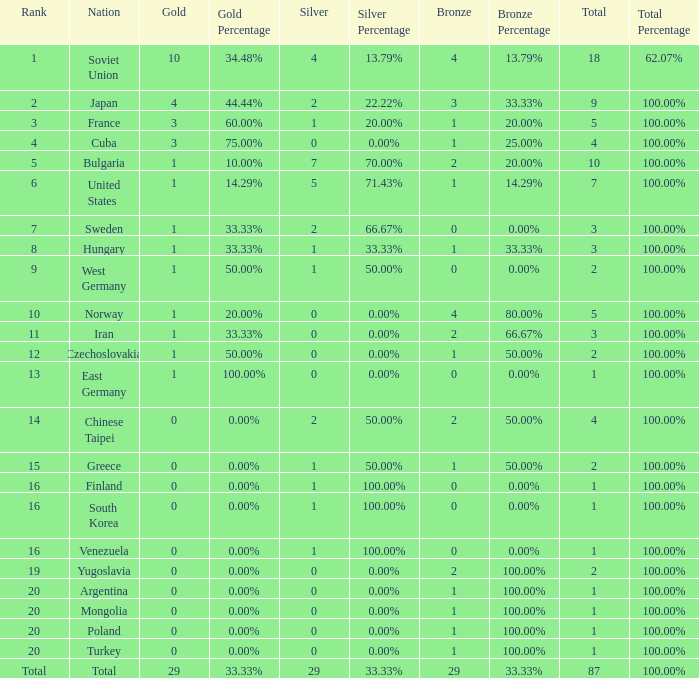What is the sum of gold medals for a rank of 14? 0.0. 